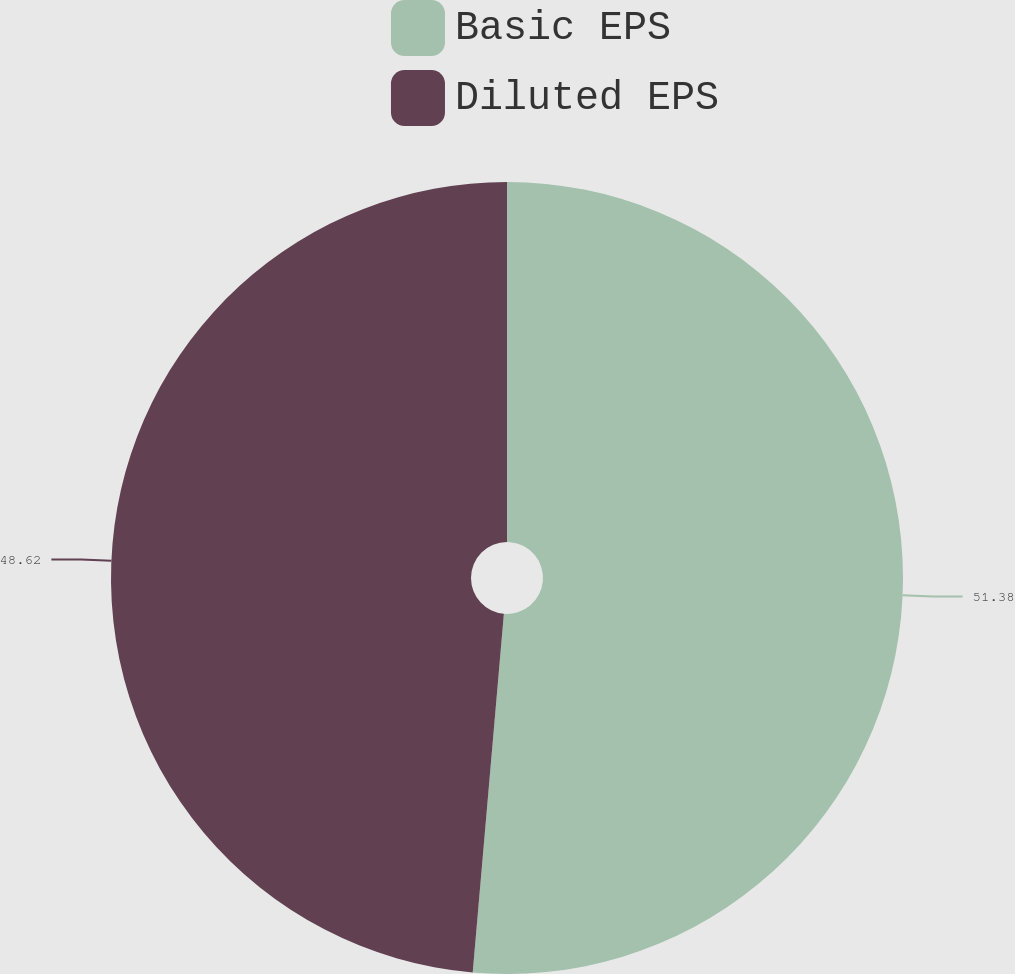Convert chart. <chart><loc_0><loc_0><loc_500><loc_500><pie_chart><fcel>Basic EPS<fcel>Diluted EPS<nl><fcel>51.38%<fcel>48.62%<nl></chart> 